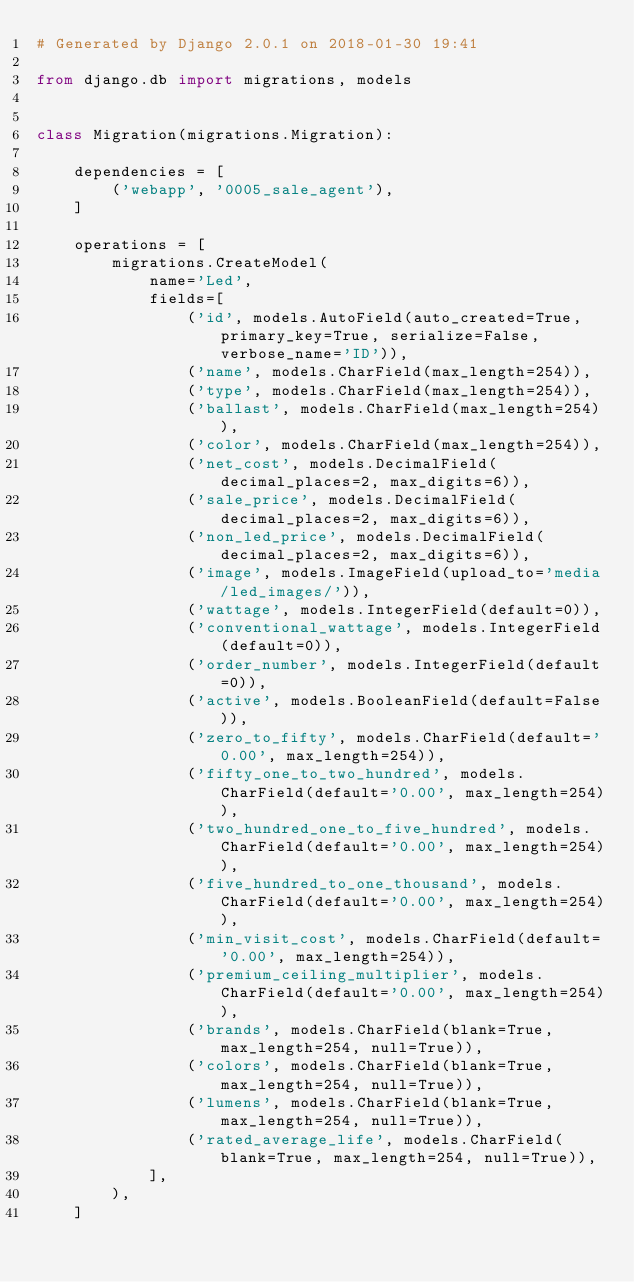<code> <loc_0><loc_0><loc_500><loc_500><_Python_># Generated by Django 2.0.1 on 2018-01-30 19:41

from django.db import migrations, models


class Migration(migrations.Migration):

    dependencies = [
        ('webapp', '0005_sale_agent'),
    ]

    operations = [
        migrations.CreateModel(
            name='Led',
            fields=[
                ('id', models.AutoField(auto_created=True, primary_key=True, serialize=False, verbose_name='ID')),
                ('name', models.CharField(max_length=254)),
                ('type', models.CharField(max_length=254)),
                ('ballast', models.CharField(max_length=254)),
                ('color', models.CharField(max_length=254)),
                ('net_cost', models.DecimalField(decimal_places=2, max_digits=6)),
                ('sale_price', models.DecimalField(decimal_places=2, max_digits=6)),
                ('non_led_price', models.DecimalField(decimal_places=2, max_digits=6)),
                ('image', models.ImageField(upload_to='media/led_images/')),
                ('wattage', models.IntegerField(default=0)),
                ('conventional_wattage', models.IntegerField(default=0)),
                ('order_number', models.IntegerField(default=0)),
                ('active', models.BooleanField(default=False)),
                ('zero_to_fifty', models.CharField(default='0.00', max_length=254)),
                ('fifty_one_to_two_hundred', models.CharField(default='0.00', max_length=254)),
                ('two_hundred_one_to_five_hundred', models.CharField(default='0.00', max_length=254)),
                ('five_hundred_to_one_thousand', models.CharField(default='0.00', max_length=254)),
                ('min_visit_cost', models.CharField(default='0.00', max_length=254)),
                ('premium_ceiling_multiplier', models.CharField(default='0.00', max_length=254)),
                ('brands', models.CharField(blank=True, max_length=254, null=True)),
                ('colors', models.CharField(blank=True, max_length=254, null=True)),
                ('lumens', models.CharField(blank=True, max_length=254, null=True)),
                ('rated_average_life', models.CharField(blank=True, max_length=254, null=True)),
            ],
        ),
    ]
</code> 